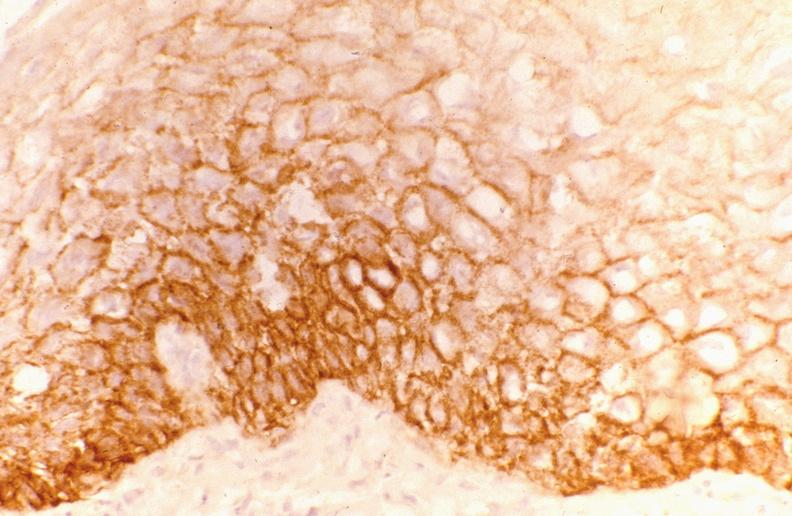what is present?
Answer the question using a single word or phrase. Gastrointestinal 